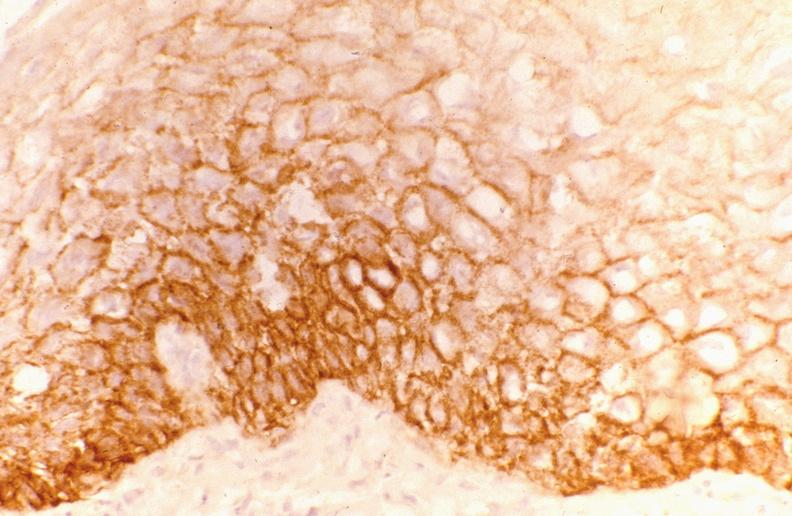what is present?
Answer the question using a single word or phrase. Gastrointestinal 